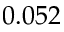Convert formula to latex. <formula><loc_0><loc_0><loc_500><loc_500>0 . 0 5 2</formula> 